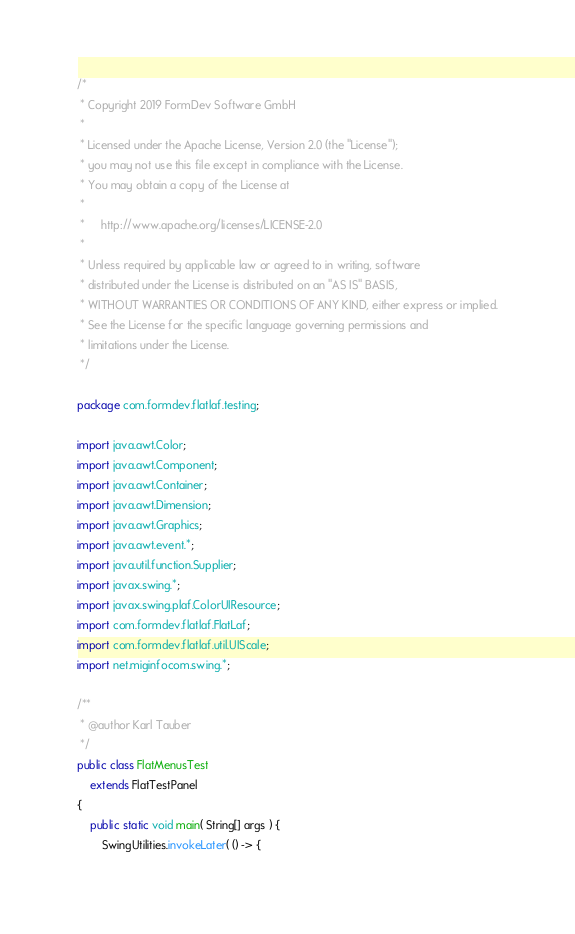<code> <loc_0><loc_0><loc_500><loc_500><_Java_>/*
 * Copyright 2019 FormDev Software GmbH
 *
 * Licensed under the Apache License, Version 2.0 (the "License");
 * you may not use this file except in compliance with the License.
 * You may obtain a copy of the License at
 *
 *     http://www.apache.org/licenses/LICENSE-2.0
 *
 * Unless required by applicable law or agreed to in writing, software
 * distributed under the License is distributed on an "AS IS" BASIS,
 * WITHOUT WARRANTIES OR CONDITIONS OF ANY KIND, either express or implied.
 * See the License for the specific language governing permissions and
 * limitations under the License.
 */

package com.formdev.flatlaf.testing;

import java.awt.Color;
import java.awt.Component;
import java.awt.Container;
import java.awt.Dimension;
import java.awt.Graphics;
import java.awt.event.*;
import java.util.function.Supplier;
import javax.swing.*;
import javax.swing.plaf.ColorUIResource;
import com.formdev.flatlaf.FlatLaf;
import com.formdev.flatlaf.util.UIScale;
import net.miginfocom.swing.*;

/**
 * @author Karl Tauber
 */
public class FlatMenusTest
	extends FlatTestPanel
{
	public static void main( String[] args ) {
		SwingUtilities.invokeLater( () -> {</code> 